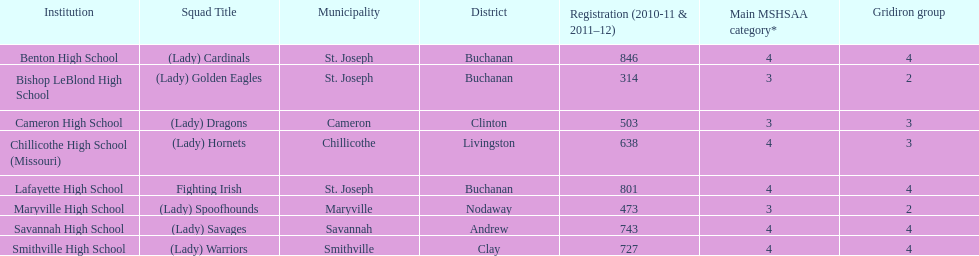How many are enrolled at each school? Benton High School, 846, Bishop LeBlond High School, 314, Cameron High School, 503, Chillicothe High School (Missouri), 638, Lafayette High School, 801, Maryville High School, 473, Savannah High School, 743, Smithville High School, 727. Which school has at only three football classes? Cameron High School, 3, Chillicothe High School (Missouri), 3. Which school has 638 enrolled and 3 football classes? Chillicothe High School (Missouri). Could you parse the entire table as a dict? {'header': ['Institution', 'Squad Title', 'Municipality', 'District', 'Registration (2010-11 & 2011–12)', 'Main MSHSAA category*', 'Gridiron group'], 'rows': [['Benton High School', '(Lady) Cardinals', 'St. Joseph', 'Buchanan', '846', '4', '4'], ['Bishop LeBlond High School', '(Lady) Golden Eagles', 'St. Joseph', 'Buchanan', '314', '3', '2'], ['Cameron High School', '(Lady) Dragons', 'Cameron', 'Clinton', '503', '3', '3'], ['Chillicothe High School (Missouri)', '(Lady) Hornets', 'Chillicothe', 'Livingston', '638', '4', '3'], ['Lafayette High School', 'Fighting Irish', 'St. Joseph', 'Buchanan', '801', '4', '4'], ['Maryville High School', '(Lady) Spoofhounds', 'Maryville', 'Nodaway', '473', '3', '2'], ['Savannah High School', '(Lady) Savages', 'Savannah', 'Andrew', '743', '4', '4'], ['Smithville High School', '(Lady) Warriors', 'Smithville', 'Clay', '727', '4', '4']]} 